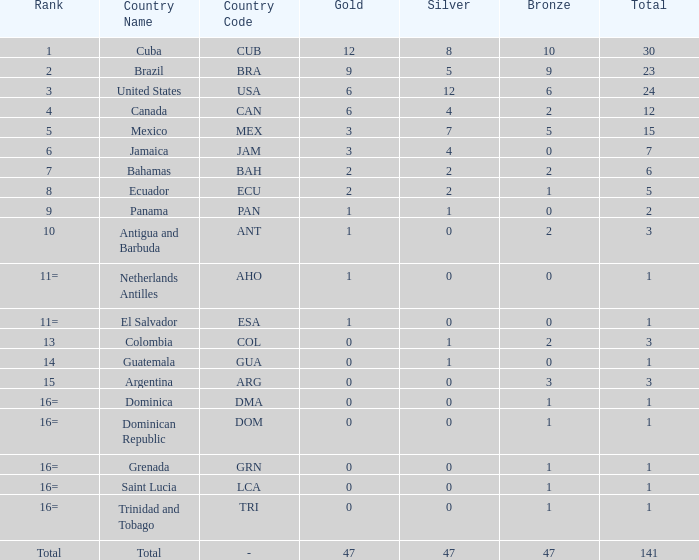What is the total gold with a total less than 1? None. 